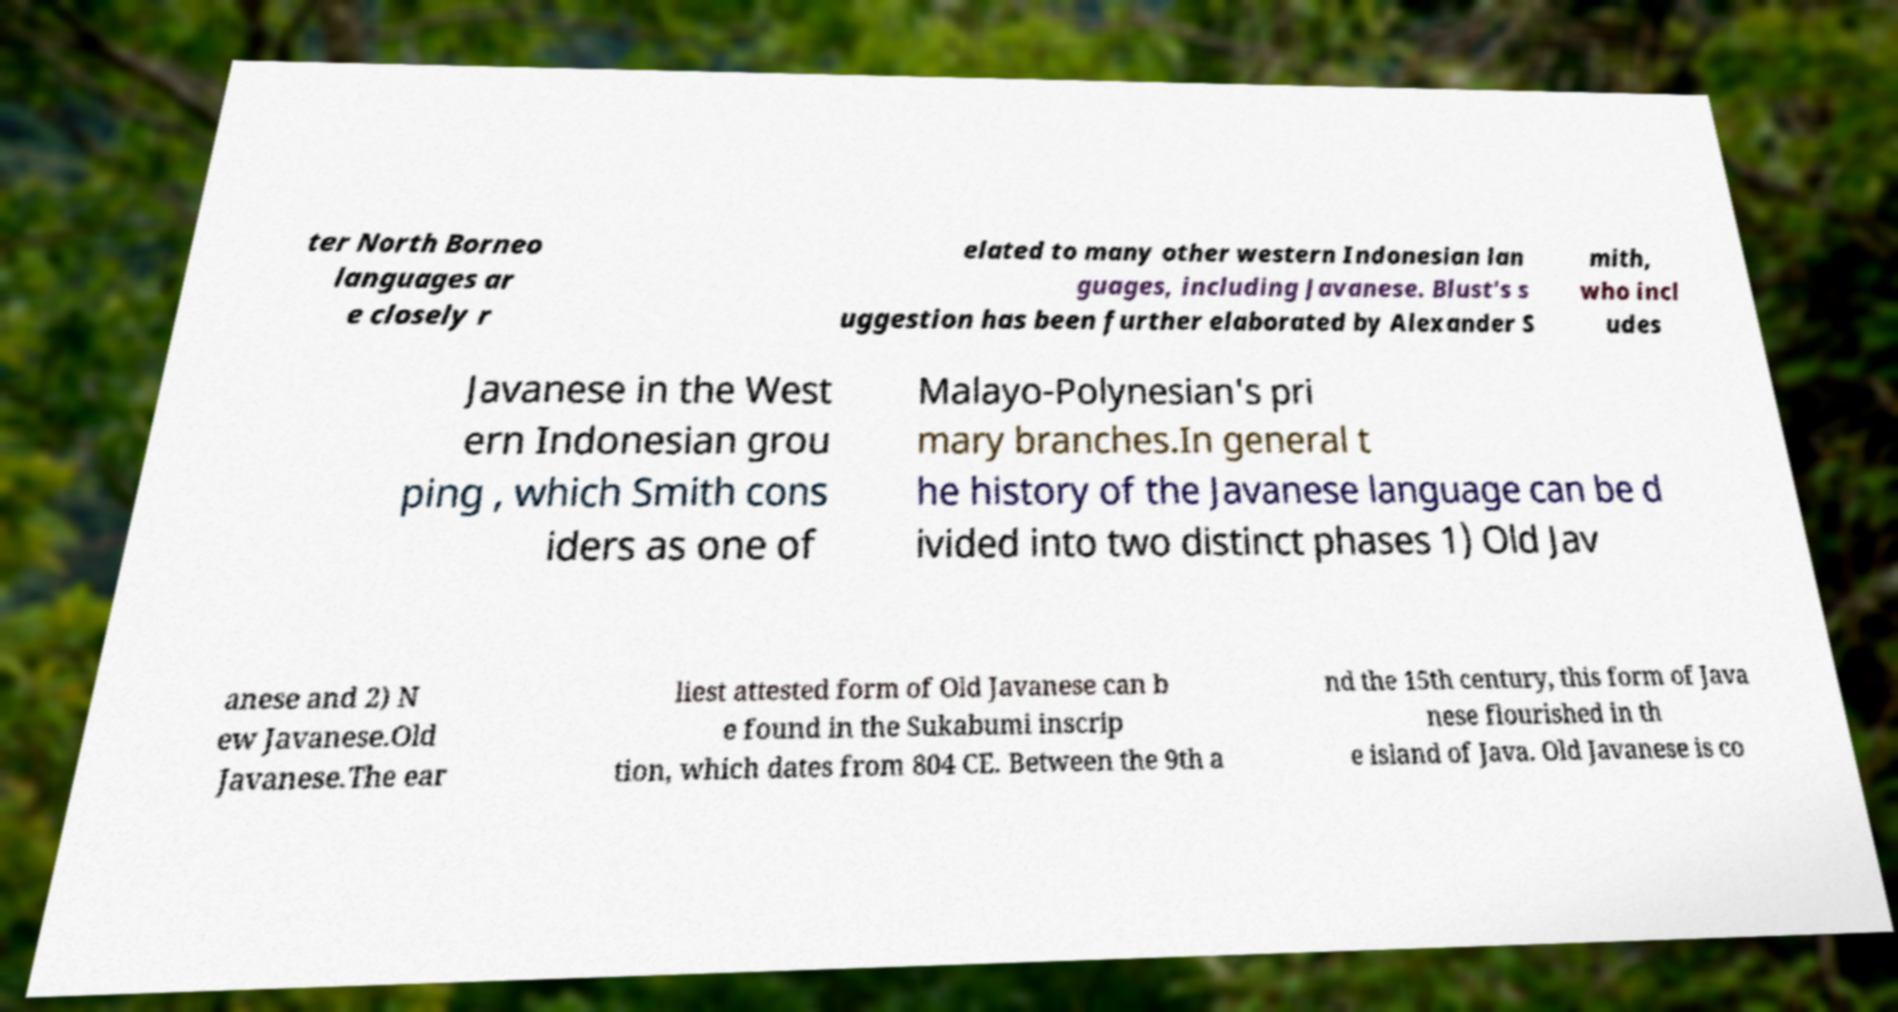Please read and relay the text visible in this image. What does it say? ter North Borneo languages ar e closely r elated to many other western Indonesian lan guages, including Javanese. Blust's s uggestion has been further elaborated by Alexander S mith, who incl udes Javanese in the West ern Indonesian grou ping , which Smith cons iders as one of Malayo-Polynesian's pri mary branches.In general t he history of the Javanese language can be d ivided into two distinct phases 1) Old Jav anese and 2) N ew Javanese.Old Javanese.The ear liest attested form of Old Javanese can b e found in the Sukabumi inscrip tion, which dates from 804 CE. Between the 9th a nd the 15th century, this form of Java nese flourished in th e island of Java. Old Javanese is co 